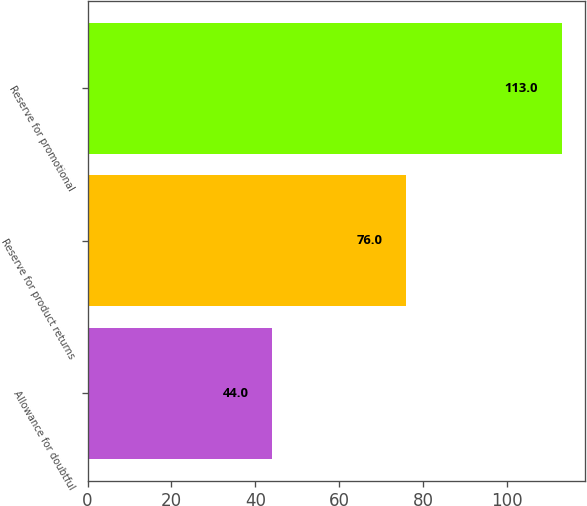<chart> <loc_0><loc_0><loc_500><loc_500><bar_chart><fcel>Allowance for doubtful<fcel>Reserve for product returns<fcel>Reserve for promotional<nl><fcel>44<fcel>76<fcel>113<nl></chart> 